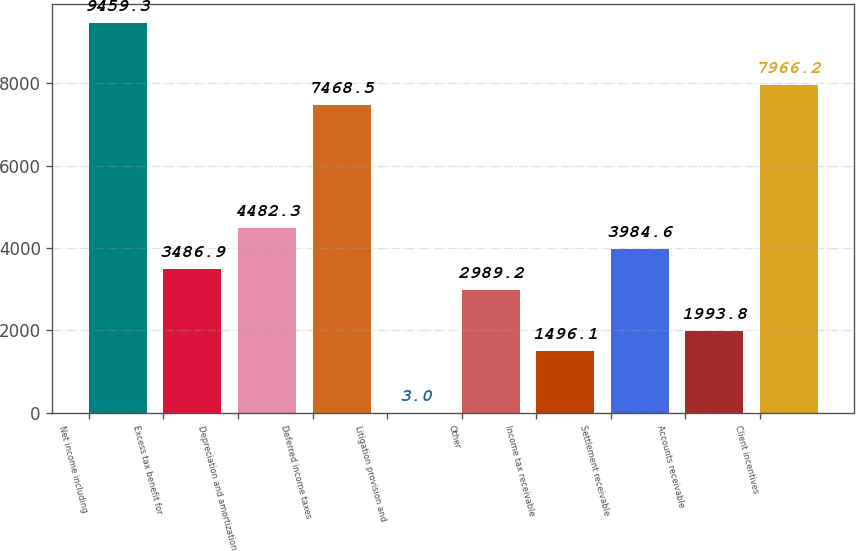Convert chart. <chart><loc_0><loc_0><loc_500><loc_500><bar_chart><fcel>Net income including<fcel>Excess tax benefit for<fcel>Depreciation and amortization<fcel>Deferred income taxes<fcel>Litigation provision and<fcel>Other<fcel>Income tax receivable<fcel>Settlement receivable<fcel>Accounts receivable<fcel>Client incentives<nl><fcel>9459.3<fcel>3486.9<fcel>4482.3<fcel>7468.5<fcel>3<fcel>2989.2<fcel>1496.1<fcel>3984.6<fcel>1993.8<fcel>7966.2<nl></chart> 